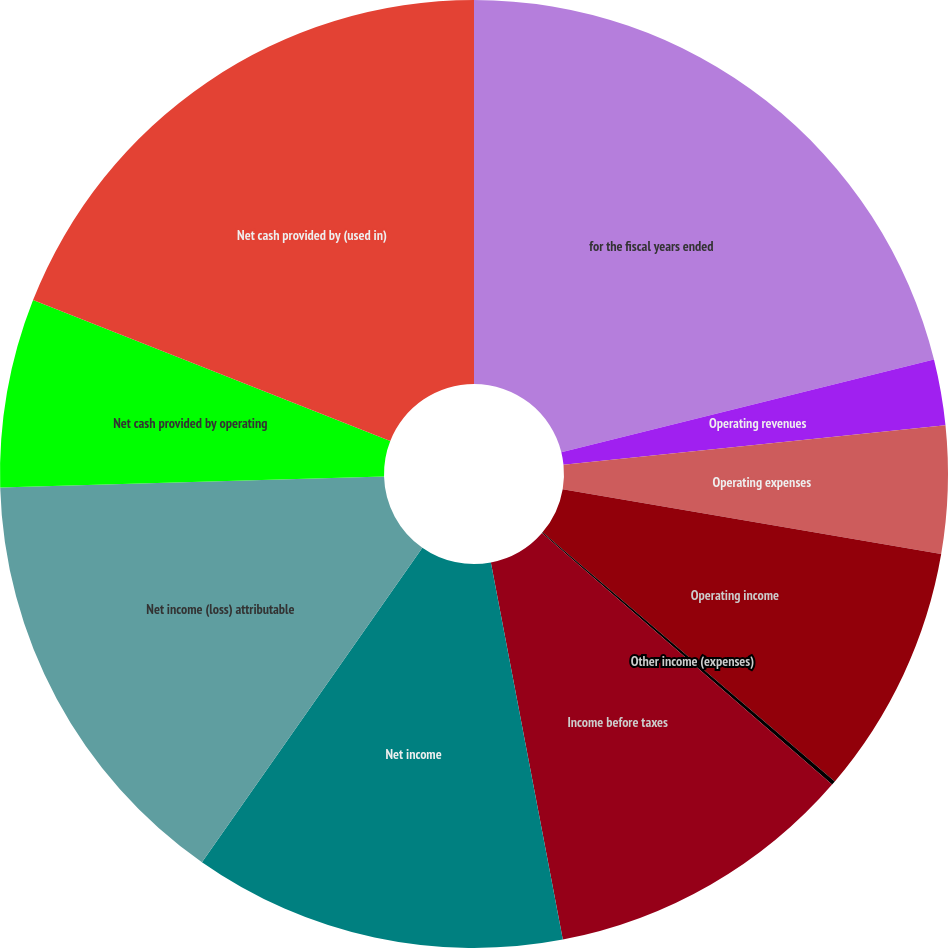Convert chart to OTSL. <chart><loc_0><loc_0><loc_500><loc_500><pie_chart><fcel>for the fiscal years ended<fcel>Operating revenues<fcel>Operating expenses<fcel>Operating income<fcel>Other income (expenses)<fcel>Income before taxes<fcel>Net income<fcel>Net income (loss) attributable<fcel>Net cash provided by operating<fcel>Net cash provided by (used in)<nl><fcel>21.12%<fcel>2.24%<fcel>4.34%<fcel>8.53%<fcel>0.14%<fcel>10.63%<fcel>12.73%<fcel>14.82%<fcel>6.43%<fcel>19.02%<nl></chart> 